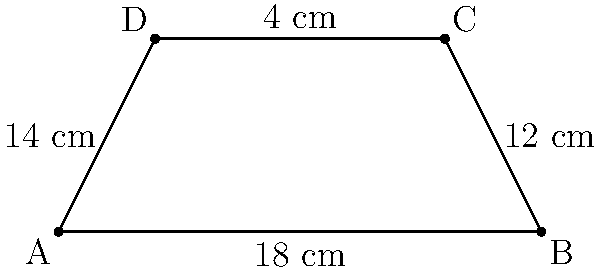You're designing a custom trapezoid-shaped mixing console surface for your garage band's unique sound setup. The parallel sides measure 18 cm and 4 cm, while the non-parallel sides are 12 cm and 14 cm. What is the area of this mixing console surface? To find the area of the trapezoid-shaped mixing console surface, we'll use the formula for the area of a trapezoid:

$$A = \frac{1}{2}(b_1 + b_2)h$$

Where:
$A$ = Area
$b_1$ and $b_2$ = Lengths of the parallel sides
$h$ = Height (perpendicular distance between the parallel sides)

Given:
- Parallel sides: 18 cm and 4 cm
- Non-parallel sides: 12 cm and 14 cm

Step 1: Identify $b_1$ and $b_2$
$b_1 = 18$ cm
$b_2 = 4$ cm

Step 2: Calculate the height ($h$) using the Pythagorean theorem
Let $x$ be the difference in the projections of the non-parallel sides on the base.
$14^2 = x^2 + h^2$
$12^2 = (18 - 4 - x)^2 + h^2$

Solving these equations:
$h = 4$ cm

Step 3: Apply the area formula
$$A = \frac{1}{2}(18 + 4) \times 4$$
$$A = \frac{1}{2}(22) \times 4$$
$$A = 11 \times 4$$
$$A = 44$$

Therefore, the area of the trapezoid-shaped mixing console surface is 44 square centimeters.
Answer: 44 cm² 